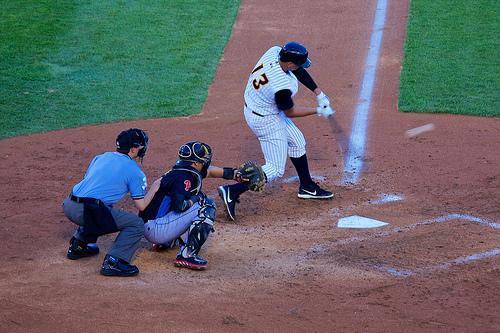How many people are shown?
Give a very brief answer. 3. 